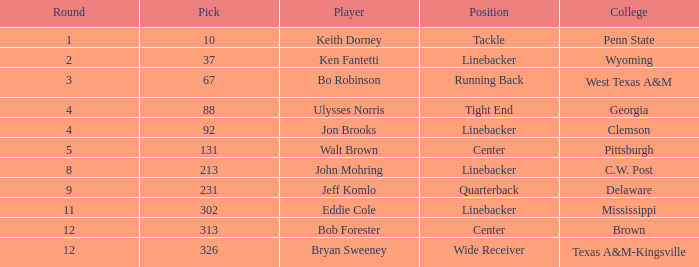What is the university selection for 213? C.W. Post. 